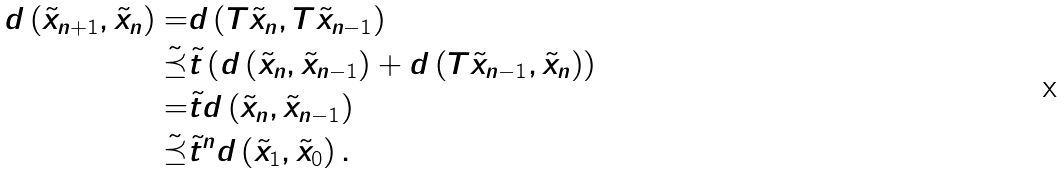Convert formula to latex. <formula><loc_0><loc_0><loc_500><loc_500>d \left ( \tilde { x } _ { n + 1 } , \tilde { x } _ { n } \right ) = & d \left ( T \tilde { x } _ { n } , T \tilde { x } _ { n - 1 } \right ) \\ \tilde { \preceq } & \tilde { t } \left ( d \left ( \tilde { x } _ { n } , \tilde { x } _ { n - 1 } \right ) + d \left ( T \tilde { x } _ { n - 1 } , \tilde { x } _ { n } \right ) \right ) \\ = & \tilde { t } d \left ( \tilde { x } _ { n } , \tilde { x } _ { n - 1 } \right ) \\ \tilde { \preceq } & \tilde { t } ^ { n } d \left ( \tilde { x } _ { 1 } , \tilde { x } _ { 0 } \right ) .</formula> 